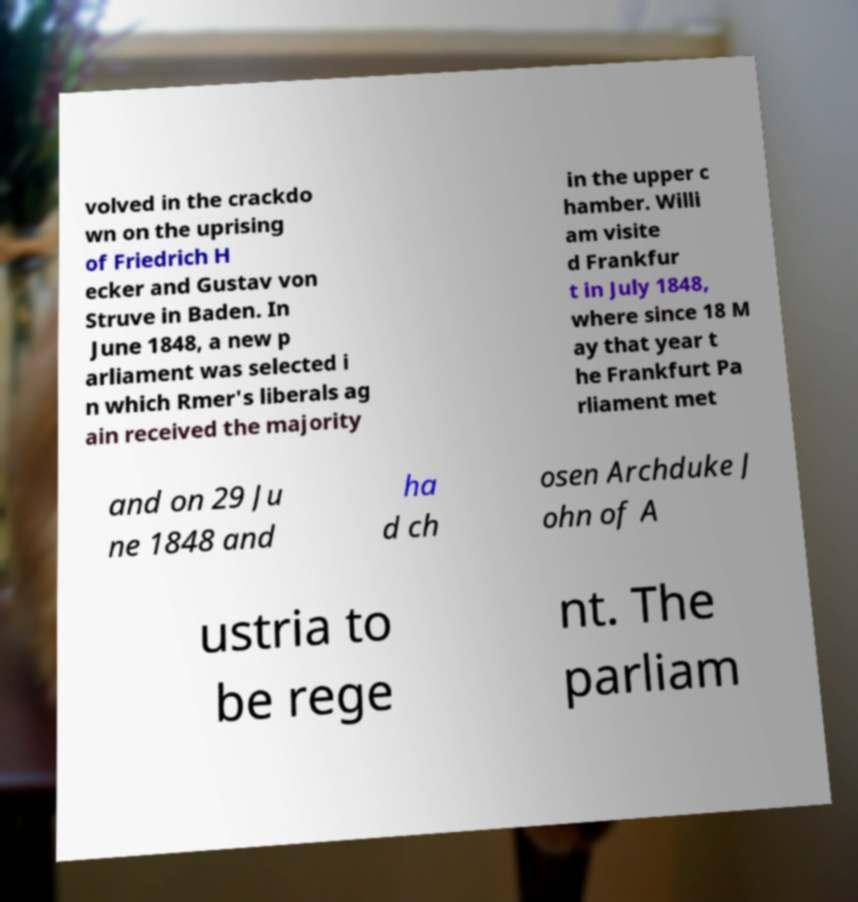Can you accurately transcribe the text from the provided image for me? volved in the crackdo wn on the uprising of Friedrich H ecker and Gustav von Struve in Baden. In June 1848, a new p arliament was selected i n which Rmer's liberals ag ain received the majority in the upper c hamber. Willi am visite d Frankfur t in July 1848, where since 18 M ay that year t he Frankfurt Pa rliament met and on 29 Ju ne 1848 and ha d ch osen Archduke J ohn of A ustria to be rege nt. The parliam 